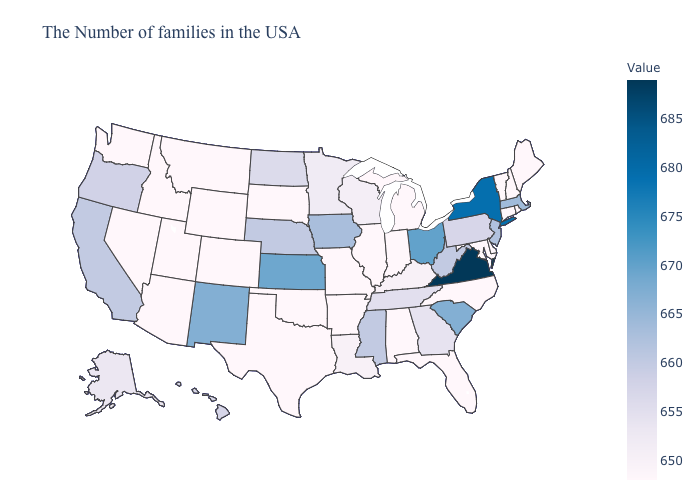Which states hav the highest value in the Northeast?
Write a very short answer. New York. Does Ohio have the highest value in the USA?
Give a very brief answer. No. Among the states that border Michigan , does Wisconsin have the lowest value?
Answer briefly. No. Does Alabama have a higher value than Pennsylvania?
Answer briefly. No. Which states have the lowest value in the Northeast?
Quick response, please. Maine, Rhode Island, New Hampshire, Vermont, Connecticut. Which states have the lowest value in the USA?
Write a very short answer. Maine, Rhode Island, New Hampshire, Vermont, Connecticut, Delaware, Maryland, North Carolina, Florida, Michigan, Indiana, Alabama, Illinois, Missouri, Arkansas, Oklahoma, Texas, South Dakota, Wyoming, Colorado, Utah, Montana, Arizona, Idaho, Nevada, Washington. Does Hawaii have the highest value in the USA?
Short answer required. No. 